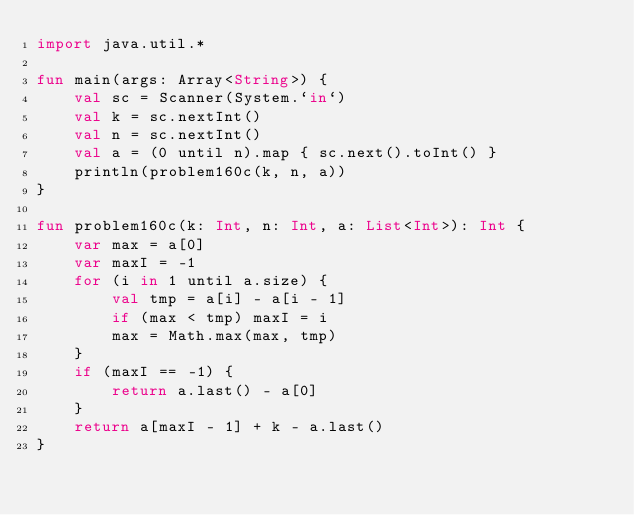Convert code to text. <code><loc_0><loc_0><loc_500><loc_500><_Kotlin_>import java.util.*

fun main(args: Array<String>) {
    val sc = Scanner(System.`in`)
    val k = sc.nextInt()
    val n = sc.nextInt()
    val a = (0 until n).map { sc.next().toInt() }
    println(problem160c(k, n, a))
}

fun problem160c(k: Int, n: Int, a: List<Int>): Int {
    var max = a[0]
    var maxI = -1
    for (i in 1 until a.size) {
        val tmp = a[i] - a[i - 1]
        if (max < tmp) maxI = i
        max = Math.max(max, tmp)
    }
    if (maxI == -1) {
        return a.last() - a[0]
    }
    return a[maxI - 1] + k - a.last()
}</code> 